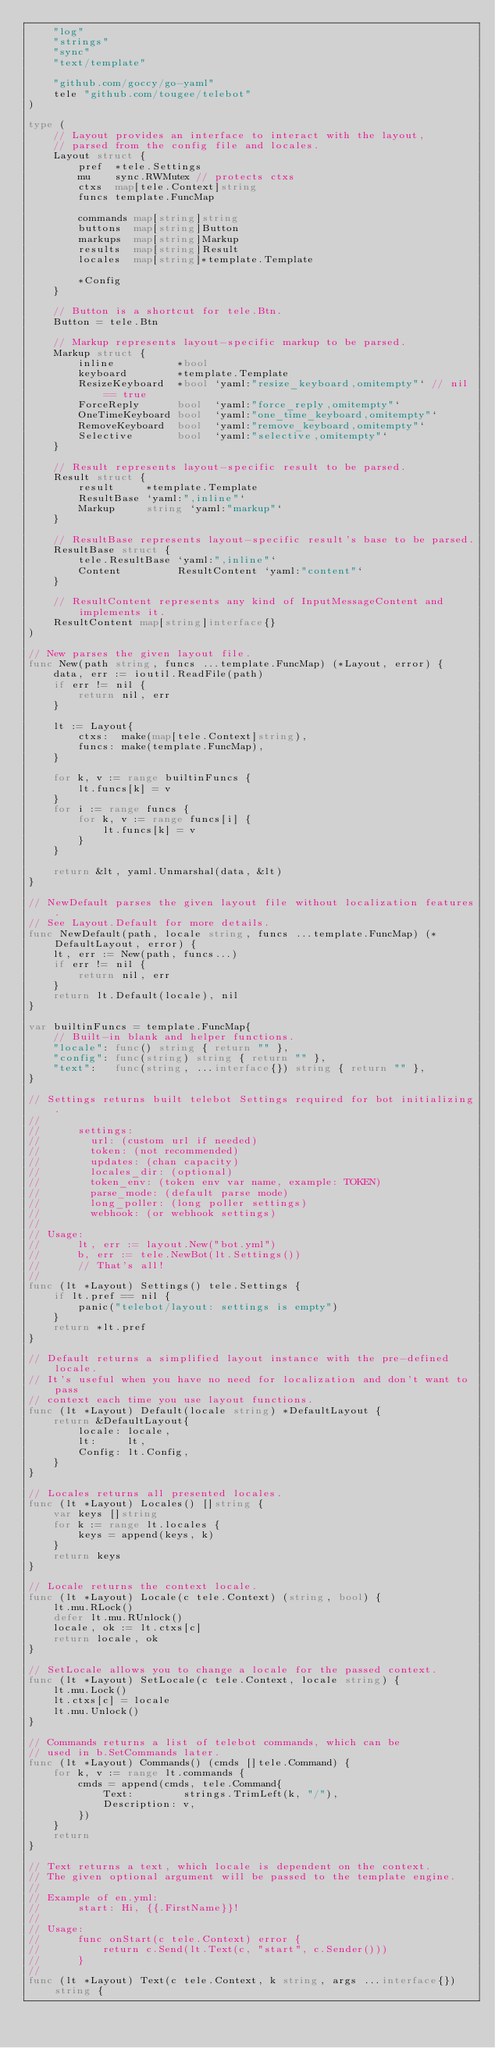Convert code to text. <code><loc_0><loc_0><loc_500><loc_500><_Go_>	"log"
	"strings"
	"sync"
	"text/template"

	"github.com/goccy/go-yaml"
	tele "github.com/tougee/telebot"
)

type (
	// Layout provides an interface to interact with the layout,
	// parsed from the config file and locales.
	Layout struct {
		pref  *tele.Settings
		mu    sync.RWMutex // protects ctxs
		ctxs  map[tele.Context]string
		funcs template.FuncMap

		commands map[string]string
		buttons  map[string]Button
		markups  map[string]Markup
		results  map[string]Result
		locales  map[string]*template.Template

		*Config
	}

	// Button is a shortcut for tele.Btn.
	Button = tele.Btn

	// Markup represents layout-specific markup to be parsed.
	Markup struct {
		inline          *bool
		keyboard        *template.Template
		ResizeKeyboard  *bool `yaml:"resize_keyboard,omitempty"` // nil == true
		ForceReply      bool  `yaml:"force_reply,omitempty"`
		OneTimeKeyboard bool  `yaml:"one_time_keyboard,omitempty"`
		RemoveKeyboard  bool  `yaml:"remove_keyboard,omitempty"`
		Selective       bool  `yaml:"selective,omitempty"`
	}

	// Result represents layout-specific result to be parsed.
	Result struct {
		result     *template.Template
		ResultBase `yaml:",inline"`
		Markup     string `yaml:"markup"`
	}

	// ResultBase represents layout-specific result's base to be parsed.
	ResultBase struct {
		tele.ResultBase `yaml:",inline"`
		Content         ResultContent `yaml:"content"`
	}

	// ResultContent represents any kind of InputMessageContent and implements it.
	ResultContent map[string]interface{}
)

// New parses the given layout file.
func New(path string, funcs ...template.FuncMap) (*Layout, error) {
	data, err := ioutil.ReadFile(path)
	if err != nil {
		return nil, err
	}

	lt := Layout{
		ctxs:  make(map[tele.Context]string),
		funcs: make(template.FuncMap),
	}

	for k, v := range builtinFuncs {
		lt.funcs[k] = v
	}
	for i := range funcs {
		for k, v := range funcs[i] {
			lt.funcs[k] = v
		}
	}

	return &lt, yaml.Unmarshal(data, &lt)
}

// NewDefault parses the given layout file without localization features.
// See Layout.Default for more details.
func NewDefault(path, locale string, funcs ...template.FuncMap) (*DefaultLayout, error) {
	lt, err := New(path, funcs...)
	if err != nil {
		return nil, err
	}
	return lt.Default(locale), nil
}

var builtinFuncs = template.FuncMap{
	// Built-in blank and helper functions.
	"locale": func() string { return "" },
	"config": func(string) string { return "" },
	"text":   func(string, ...interface{}) string { return "" },
}

// Settings returns built telebot Settings required for bot initializing.
//
//		settings:
//		  url: (custom url if needed)
//		  token: (not recommended)
//		  updates: (chan capacity)
//		  locales_dir: (optional)
//		  token_env: (token env var name, example: TOKEN)
// 		  parse_mode: (default parse mode)
// 		  long_poller: (long poller settings)
//		  webhook: (or webhook settings)
//
// Usage:
//		lt, err := layout.New("bot.yml")
//		b, err := tele.NewBot(lt.Settings())
//		// That's all!
//
func (lt *Layout) Settings() tele.Settings {
	if lt.pref == nil {
		panic("telebot/layout: settings is empty")
	}
	return *lt.pref
}

// Default returns a simplified layout instance with the pre-defined locale.
// It's useful when you have no need for localization and don't want to pass
// context each time you use layout functions.
func (lt *Layout) Default(locale string) *DefaultLayout {
	return &DefaultLayout{
		locale: locale,
		lt:     lt,
		Config: lt.Config,
	}
}

// Locales returns all presented locales.
func (lt *Layout) Locales() []string {
	var keys []string
	for k := range lt.locales {
		keys = append(keys, k)
	}
	return keys
}

// Locale returns the context locale.
func (lt *Layout) Locale(c tele.Context) (string, bool) {
	lt.mu.RLock()
	defer lt.mu.RUnlock()
	locale, ok := lt.ctxs[c]
	return locale, ok
}

// SetLocale allows you to change a locale for the passed context.
func (lt *Layout) SetLocale(c tele.Context, locale string) {
	lt.mu.Lock()
	lt.ctxs[c] = locale
	lt.mu.Unlock()
}

// Commands returns a list of telebot commands, which can be
// used in b.SetCommands later.
func (lt *Layout) Commands() (cmds []tele.Command) {
	for k, v := range lt.commands {
		cmds = append(cmds, tele.Command{
			Text:        strings.TrimLeft(k, "/"),
			Description: v,
		})
	}
	return
}

// Text returns a text, which locale is dependent on the context.
// The given optional argument will be passed to the template engine.
//
// Example of en.yml:
//		start: Hi, {{.FirstName}}!
//
// Usage:
//		func onStart(c tele.Context) error {
//			return c.Send(lt.Text(c, "start", c.Sender()))
//		}
//
func (lt *Layout) Text(c tele.Context, k string, args ...interface{}) string {</code> 